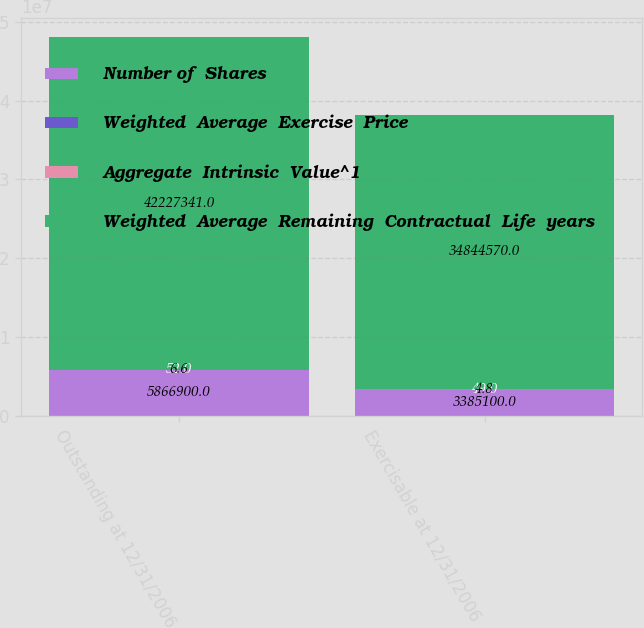Convert chart to OTSL. <chart><loc_0><loc_0><loc_500><loc_500><stacked_bar_chart><ecel><fcel>Outstanding at 12/31/2006<fcel>Exercisable at 12/31/2006<nl><fcel>Number of  Shares<fcel>5.8669e+06<fcel>3.3851e+06<nl><fcel>Weighted  Average  Exercise  Price<fcel>52<fcel>49<nl><fcel>Aggregate  Intrinsic  Value^1<fcel>6.6<fcel>4.8<nl><fcel>Weighted  Average  Remaining  Contractual  Life  years<fcel>4.22273e+07<fcel>3.48446e+07<nl></chart> 